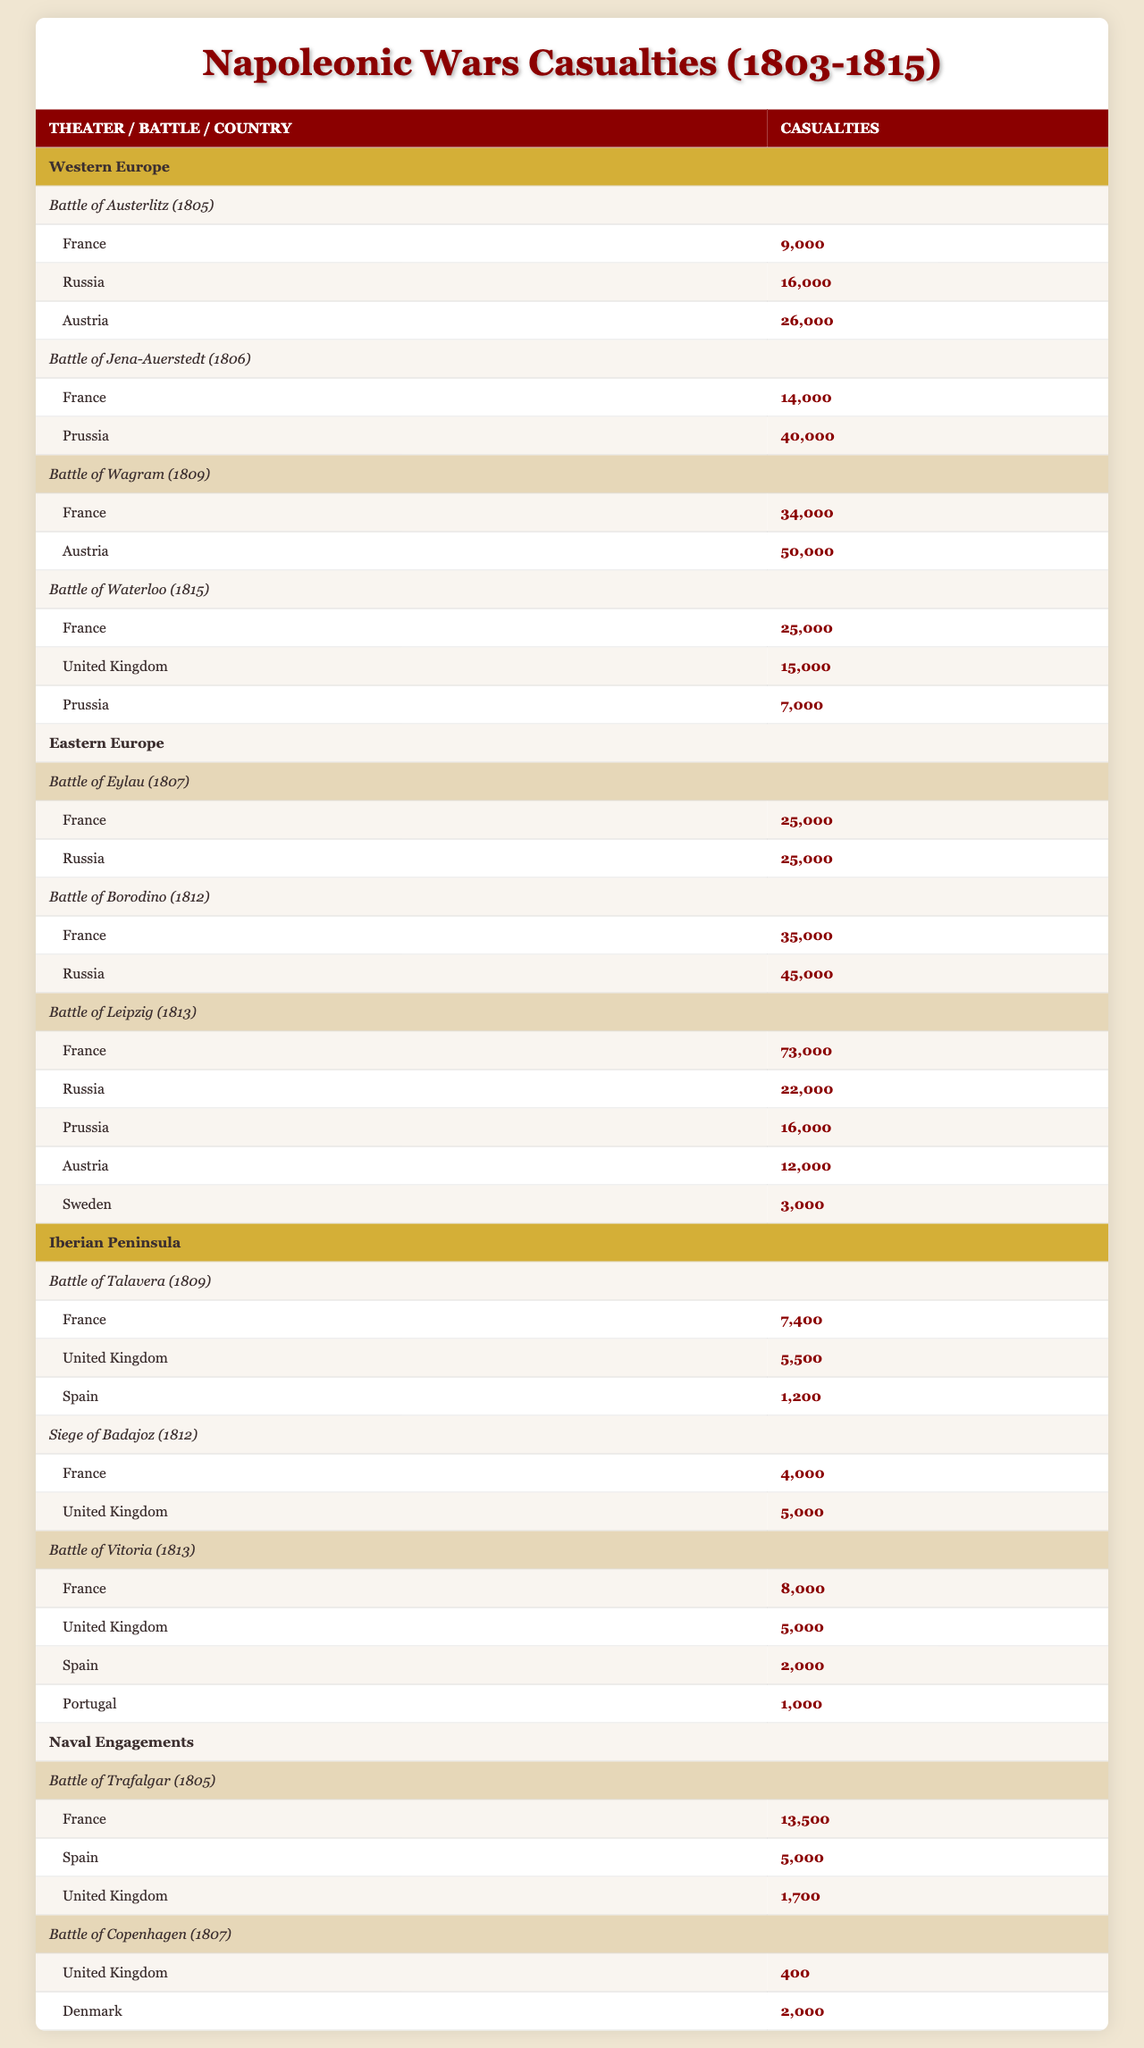What were the total casualties for the Battle of Austerlitz? The casualties for this battle are listed for France (9,000), Russia (16,000), and Austria (26,000). Summing them up: 9,000 + 16,000 + 26,000 = 51,000.
Answer: 51,000 Which nation incurred the highest casualties in the Battle of Leipzig? For the Battle of Leipzig, the casualties are: France (73,000), Russia (22,000), Prussia (16,000), Austria (12,000), and Sweden (3,000). The highest number is from France with 73,000 casualties.
Answer: France How many total casualties did the United Kingdom suffer across all battles? The battles involving the United Kingdom are Battle of Talavera (5,500), Siege of Badajoz (5,000), Battle of Vitoria (5,000), and Battle of Waterloo (15,000). Adding these up gives 5,500 + 5,000 + 5,000 + 15,000 = 30,500.
Answer: 30,500 Did France suffer more casualties in the Battle of Borodino than in the Battle of Eylau? In the Battle of Borodino, France suffered 35,000 casualties, while in the Battle of Eylau, France suffered 25,000. Since 35,000 is greater than 25,000, the statement is true.
Answer: Yes What is the total number of casualties for Austria across all battles listed? Austria appears in the following battles: Austerlitz (26,000), Wagram (50,000), and Leipzig (12,000). Summing these gives 26,000 + 50,000 + 12,000 = 88,000.
Answer: 88,000 Which battle had the most casualties for Prussia? The battles with Prussia involved are Jena-Auerstedt (40,000) and Leipzig (16,000). The highest number is from the Battle of Jena-Auerstedt with 40,000 casualties.
Answer: Jena-Auerstedt Calculate the average casualties for France across the battles they participated in during the Napoleonic Wars. France participated in multiple battles. The casualties are: Austerlitz (9,000), Jena-Auerstedt (14,000), Wagram (34,000), Waterloo (25,000), Eylau (25,000), Borodino (35,000), and Leipzig (73,000), totaling 9,000 + 14,000 + 34,000 + 25,000 + 25,000 + 35,000 + 73,000 = 219,000 casualties over 7 battles. The average then is 219,000 / 7 = 31,285.71.
Answer: Approximately 31,286 Which nation had the lowest recorded casualties in any battle? Looking through the casualties, Spain had the lowest recorded casualties of 1,200 during the Battle of Talavera.
Answer: Spain Did the United Kingdom participate in any naval engagements? The naval engagements listed include the Battle of Trafalgar and the Battle of Copenhagen, both mentioning UK casualties. Therefore, the United Kingdom did participate in naval engagements.
Answer: Yes What is the total casualty number from the naval engagements? The casualties from naval engagements include: Trafalgar (UK: 1,700; France: 13,500; Spain: 5,000, totaling 19,200) and Copenhagen (UK: 400; Denmark: 2,000, totaling 2,400). Summing these two engagements gives 19,200 + 2,400 = 21,600.
Answer: 21,600 